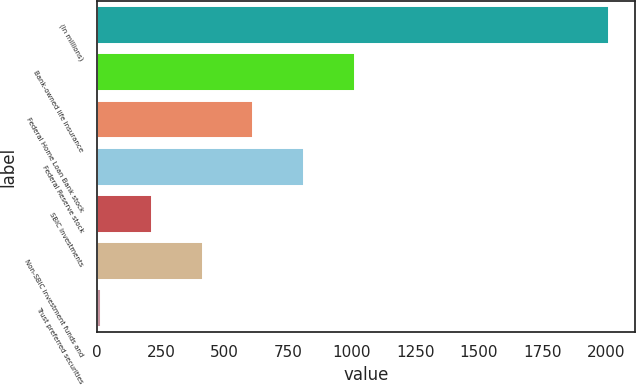<chart> <loc_0><loc_0><loc_500><loc_500><bar_chart><fcel>(In millions)<fcel>Bank-owned life insurance<fcel>Federal Home Loan Bank stock<fcel>Federal Reserve stock<fcel>SBIC investments<fcel>Non-SBIC investment funds and<fcel>Trust preferred securities<nl><fcel>2012<fcel>1013<fcel>613.4<fcel>813.2<fcel>213.8<fcel>413.6<fcel>14<nl></chart> 